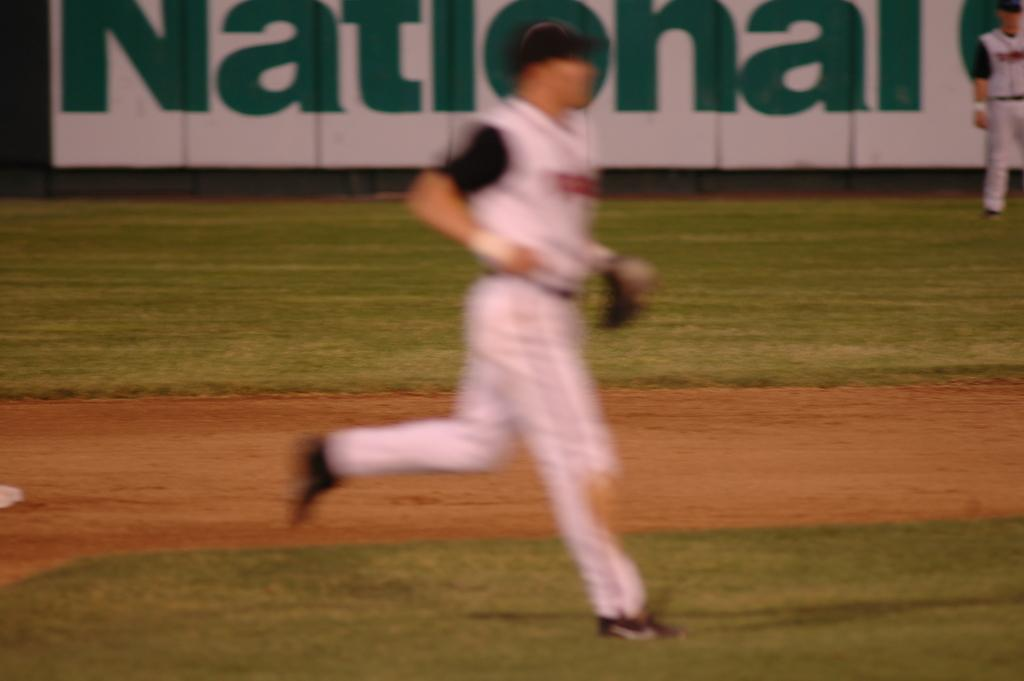<image>
Describe the image concisely. a baseball making a run on the field in front of a national banner 